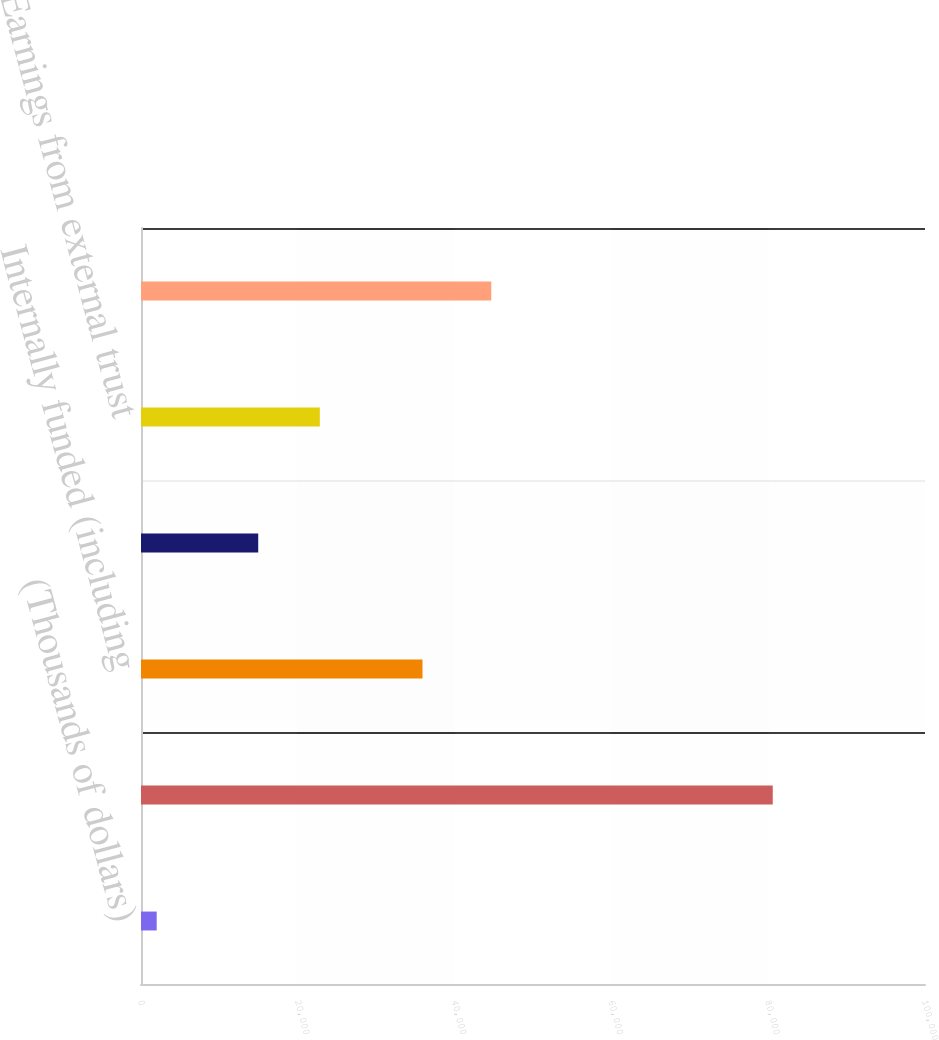Convert chart to OTSL. <chart><loc_0><loc_0><loc_500><loc_500><bar_chart><fcel>(Thousands of dollars)<fcel>Externally funded<fcel>Internally funded (including<fcel>Interest cost on externally<fcel>Earnings from external trust<fcel>Net decommissioning accruals<nl><fcel>2003<fcel>80582<fcel>35906<fcel>14952<fcel>22809.9<fcel>44676<nl></chart> 